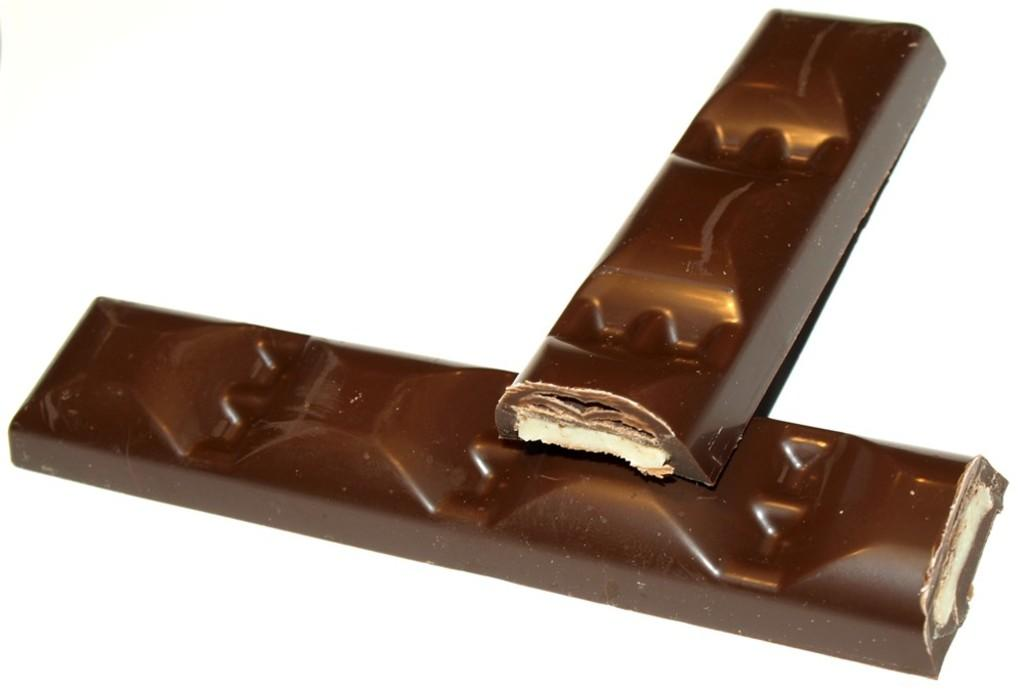What type of food items are present in the image? There are two chocolate bars in the image. Can you describe the appearance of the chocolate bars? The chocolate bars are not described in the provided facts, so we cannot provide a detailed description. How many chocolate bars are visible in the image? There are two chocolate bars visible in the image. What color is the paint on the spiders in the image? There are no spiders or paint present in the image; it only features two chocolate bars. 